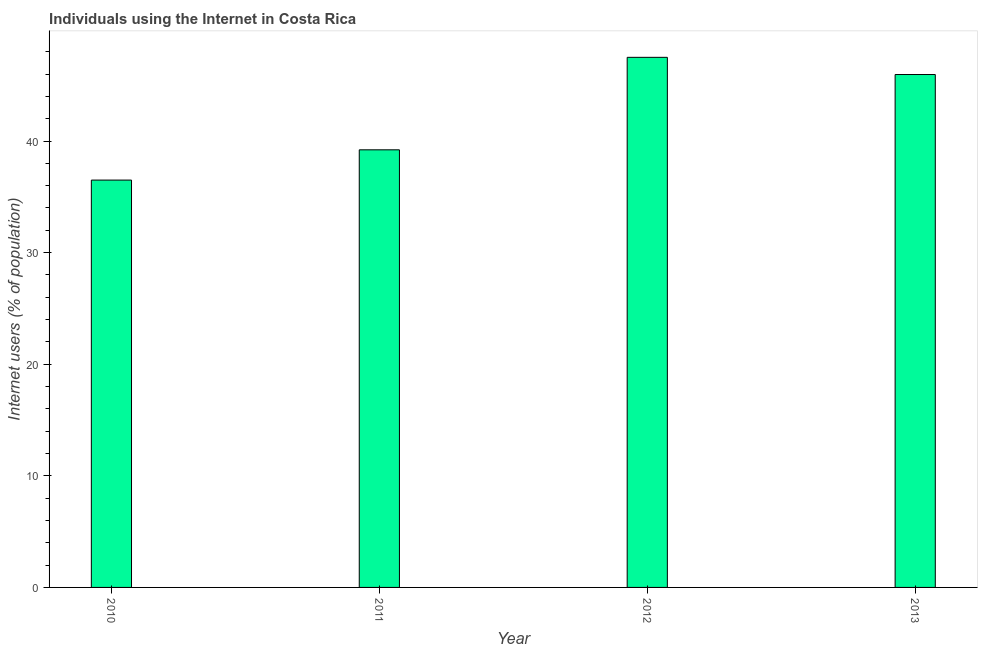What is the title of the graph?
Offer a terse response. Individuals using the Internet in Costa Rica. What is the label or title of the Y-axis?
Make the answer very short. Internet users (% of population). What is the number of internet users in 2011?
Your answer should be compact. 39.21. Across all years, what is the maximum number of internet users?
Keep it short and to the point. 47.5. Across all years, what is the minimum number of internet users?
Keep it short and to the point. 36.5. What is the sum of the number of internet users?
Offer a terse response. 169.17. What is the difference between the number of internet users in 2010 and 2012?
Offer a very short reply. -11. What is the average number of internet users per year?
Offer a very short reply. 42.29. What is the median number of internet users?
Your response must be concise. 42.59. What is the ratio of the number of internet users in 2012 to that in 2013?
Offer a terse response. 1.03. Is the difference between the number of internet users in 2010 and 2011 greater than the difference between any two years?
Offer a terse response. No. What is the difference between the highest and the second highest number of internet users?
Keep it short and to the point. 1.54. What is the difference between the highest and the lowest number of internet users?
Your response must be concise. 11. Are all the bars in the graph horizontal?
Provide a succinct answer. No. How many years are there in the graph?
Keep it short and to the point. 4. What is the difference between two consecutive major ticks on the Y-axis?
Offer a very short reply. 10. Are the values on the major ticks of Y-axis written in scientific E-notation?
Offer a terse response. No. What is the Internet users (% of population) of 2010?
Your answer should be very brief. 36.5. What is the Internet users (% of population) of 2011?
Keep it short and to the point. 39.21. What is the Internet users (% of population) in 2012?
Keep it short and to the point. 47.5. What is the Internet users (% of population) in 2013?
Provide a short and direct response. 45.96. What is the difference between the Internet users (% of population) in 2010 and 2011?
Your answer should be very brief. -2.71. What is the difference between the Internet users (% of population) in 2010 and 2013?
Give a very brief answer. -9.46. What is the difference between the Internet users (% of population) in 2011 and 2012?
Offer a very short reply. -8.29. What is the difference between the Internet users (% of population) in 2011 and 2013?
Provide a succinct answer. -6.75. What is the difference between the Internet users (% of population) in 2012 and 2013?
Your response must be concise. 1.54. What is the ratio of the Internet users (% of population) in 2010 to that in 2012?
Ensure brevity in your answer.  0.77. What is the ratio of the Internet users (% of population) in 2010 to that in 2013?
Your answer should be very brief. 0.79. What is the ratio of the Internet users (% of population) in 2011 to that in 2012?
Your response must be concise. 0.83. What is the ratio of the Internet users (% of population) in 2011 to that in 2013?
Keep it short and to the point. 0.85. What is the ratio of the Internet users (% of population) in 2012 to that in 2013?
Your response must be concise. 1.03. 